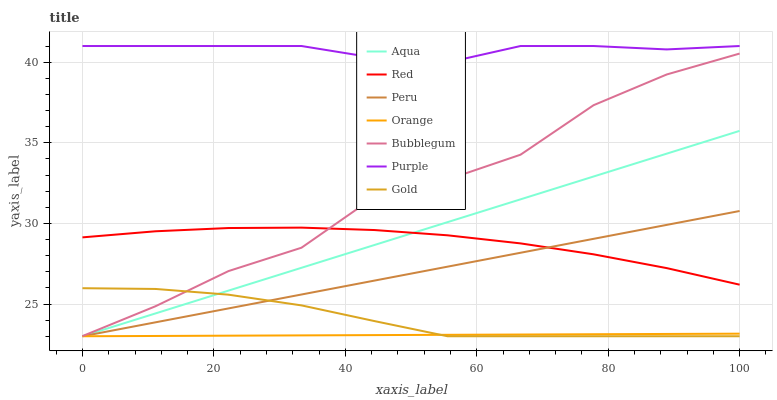Does Orange have the minimum area under the curve?
Answer yes or no. Yes. Does Purple have the maximum area under the curve?
Answer yes or no. Yes. Does Aqua have the minimum area under the curve?
Answer yes or no. No. Does Aqua have the maximum area under the curve?
Answer yes or no. No. Is Aqua the smoothest?
Answer yes or no. Yes. Is Bubblegum the roughest?
Answer yes or no. Yes. Is Purple the smoothest?
Answer yes or no. No. Is Purple the roughest?
Answer yes or no. No. Does Purple have the lowest value?
Answer yes or no. No. Does Purple have the highest value?
Answer yes or no. Yes. Does Aqua have the highest value?
Answer yes or no. No. Is Gold less than Red?
Answer yes or no. Yes. Is Bubblegum greater than Aqua?
Answer yes or no. Yes. Does Bubblegum intersect Red?
Answer yes or no. Yes. Is Bubblegum less than Red?
Answer yes or no. No. Is Bubblegum greater than Red?
Answer yes or no. No. Does Gold intersect Red?
Answer yes or no. No. 